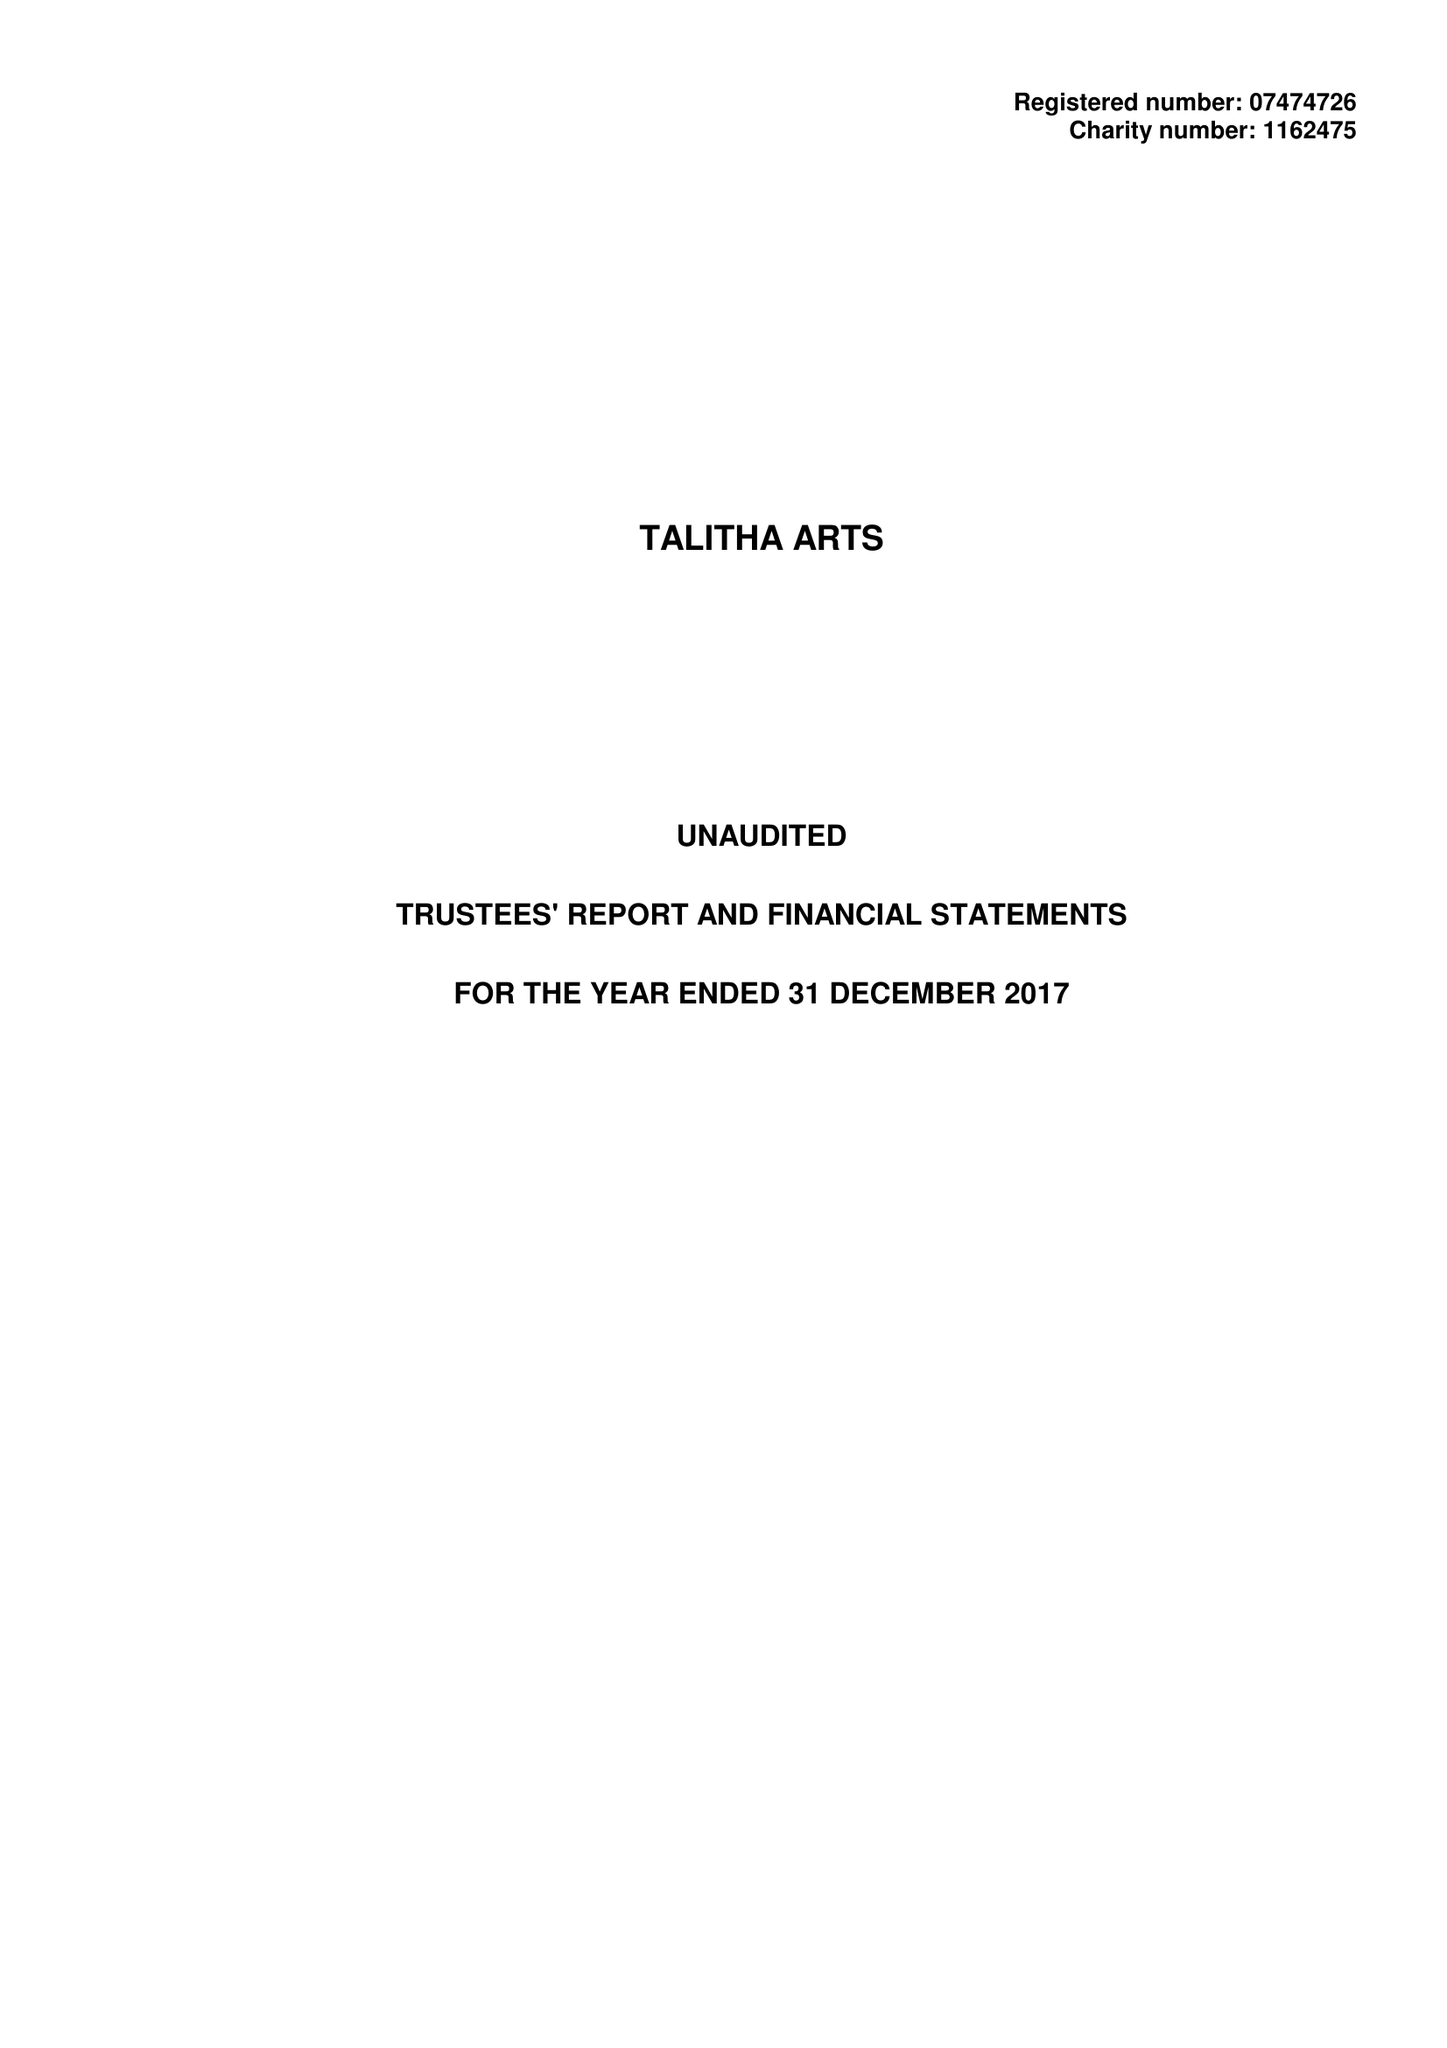What is the value for the charity_name?
Answer the question using a single word or phrase. Talitha Arts 